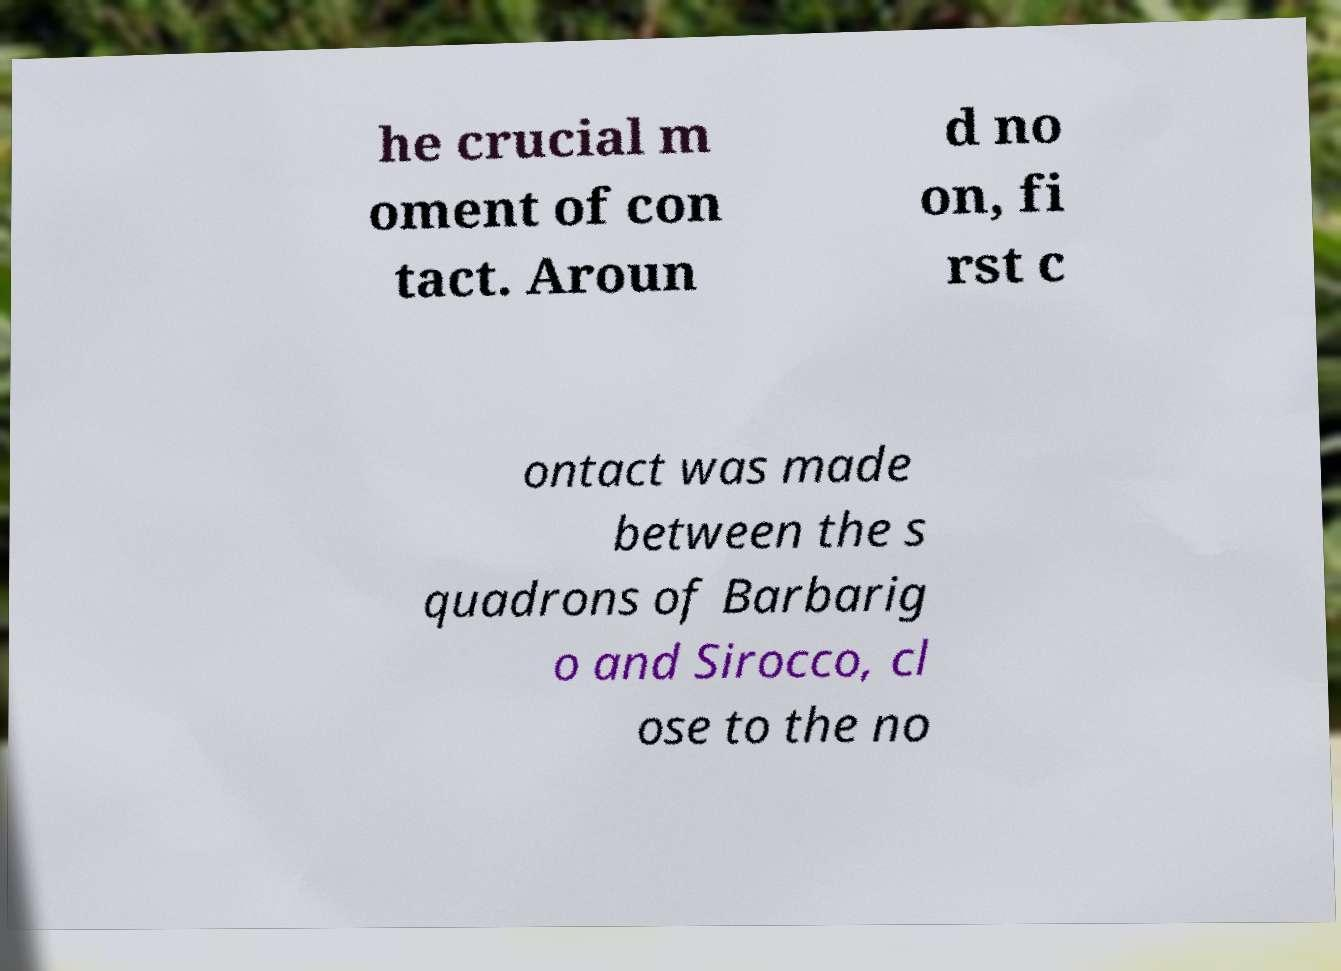I need the written content from this picture converted into text. Can you do that? he crucial m oment of con tact. Aroun d no on, fi rst c ontact was made between the s quadrons of Barbarig o and Sirocco, cl ose to the no 